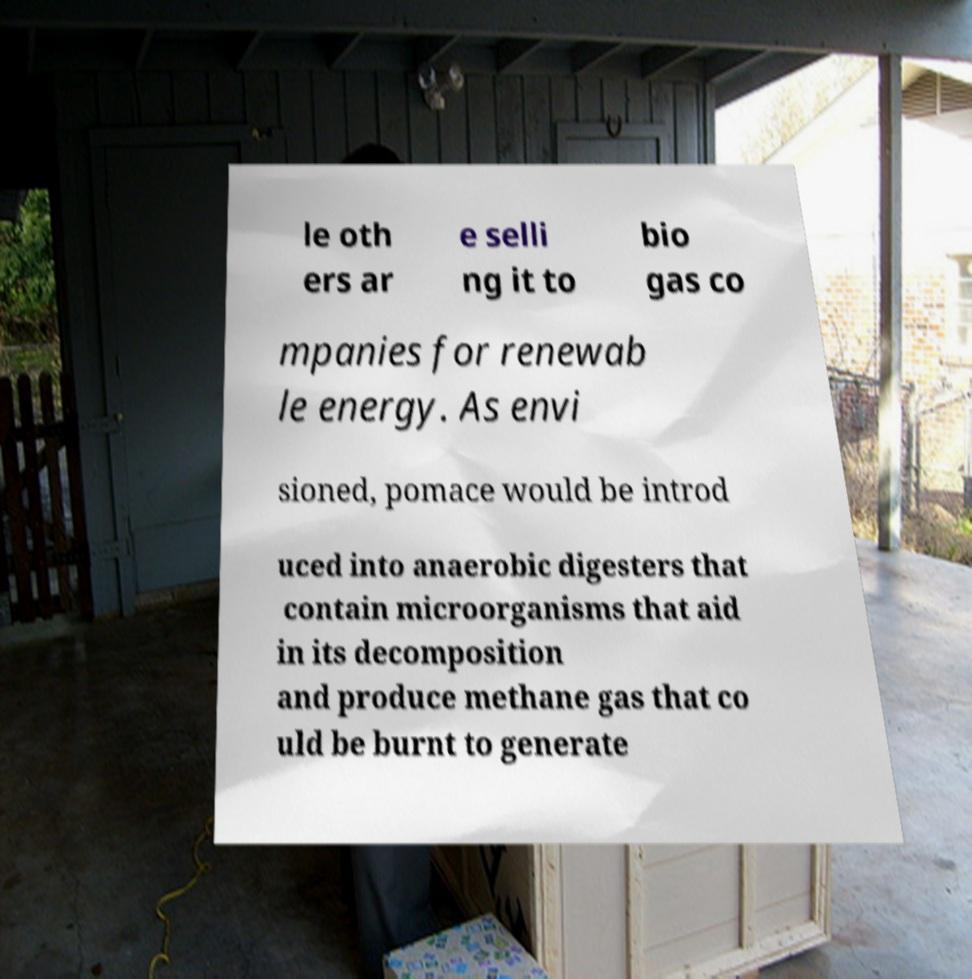Can you read and provide the text displayed in the image?This photo seems to have some interesting text. Can you extract and type it out for me? le oth ers ar e selli ng it to bio gas co mpanies for renewab le energy. As envi sioned, pomace would be introd uced into anaerobic digesters that contain microorganisms that aid in its decomposition and produce methane gas that co uld be burnt to generate 